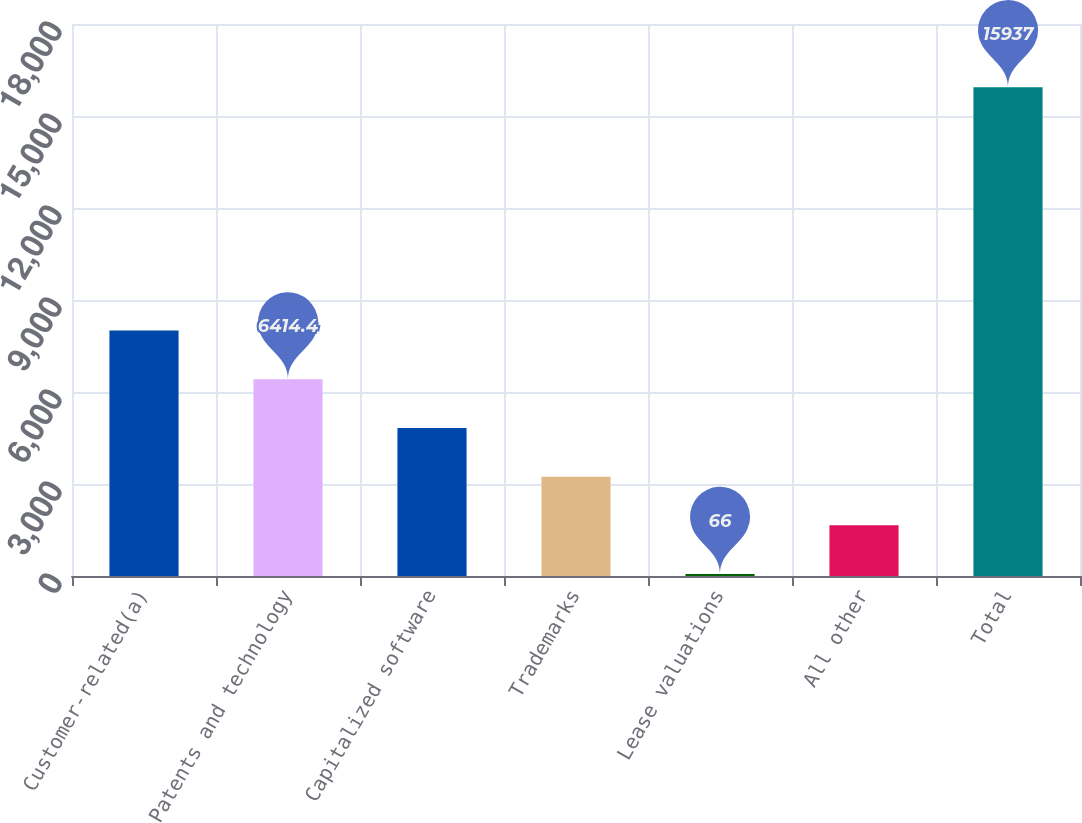<chart> <loc_0><loc_0><loc_500><loc_500><bar_chart><fcel>Customer-related(a)<fcel>Patents and technology<fcel>Capitalized software<fcel>Trademarks<fcel>Lease valuations<fcel>All other<fcel>Total<nl><fcel>8001.5<fcel>6414.4<fcel>4827.3<fcel>3240.2<fcel>66<fcel>1653.1<fcel>15937<nl></chart> 